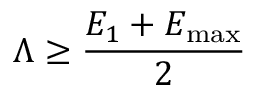Convert formula to latex. <formula><loc_0><loc_0><loc_500><loc_500>\Lambda \geq \frac { E _ { 1 } + E _ { \max } } { 2 }</formula> 